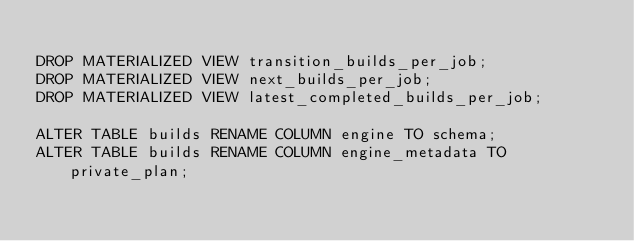<code> <loc_0><loc_0><loc_500><loc_500><_SQL_>
DROP MATERIALIZED VIEW transition_builds_per_job;
DROP MATERIALIZED VIEW next_builds_per_job;
DROP MATERIALIZED VIEW latest_completed_builds_per_job;

ALTER TABLE builds RENAME COLUMN engine TO schema;
ALTER TABLE builds RENAME COLUMN engine_metadata TO private_plan;

</code> 